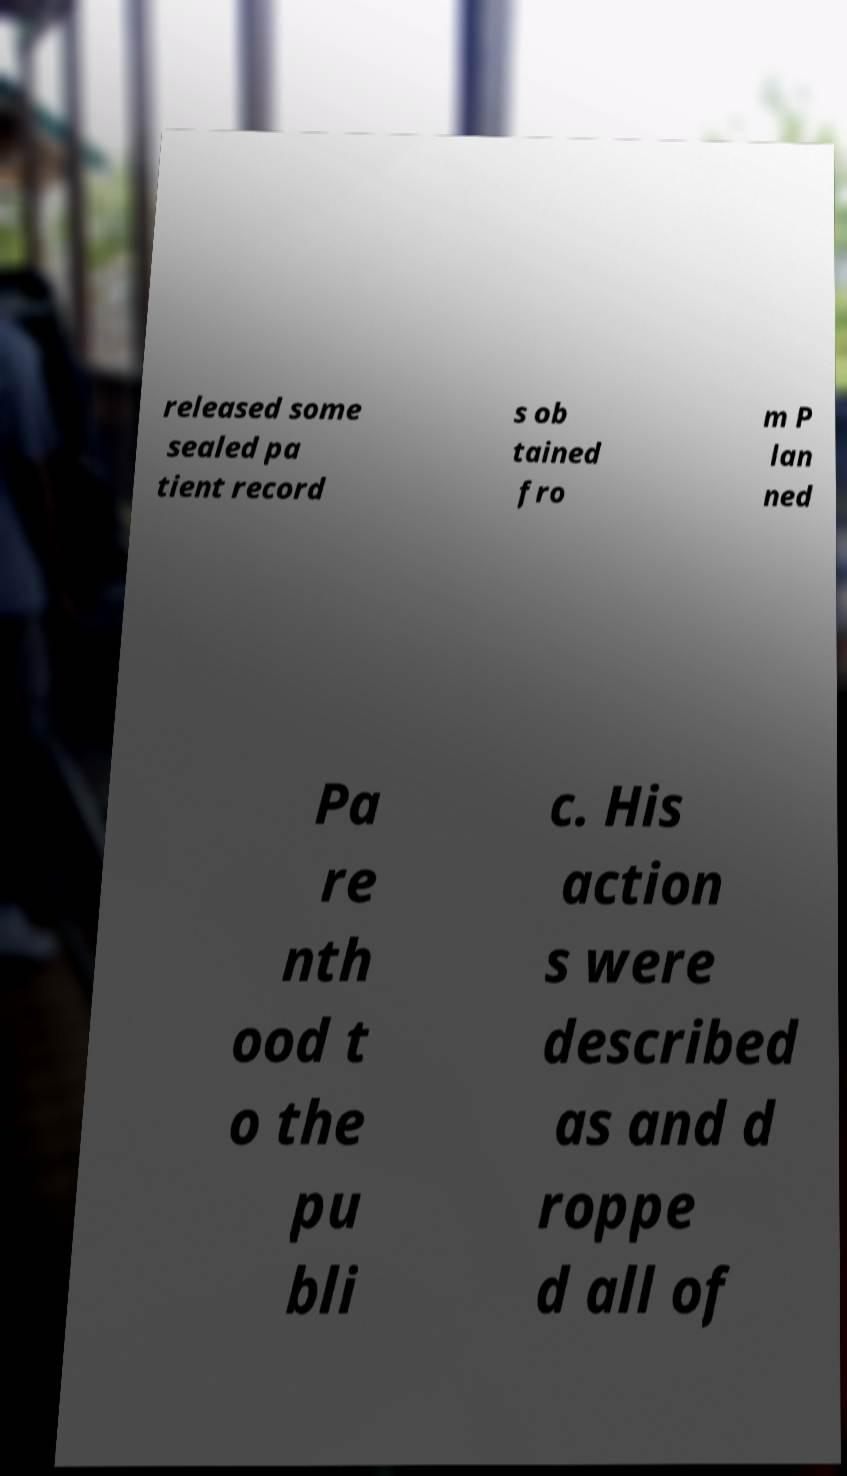I need the written content from this picture converted into text. Can you do that? released some sealed pa tient record s ob tained fro m P lan ned Pa re nth ood t o the pu bli c. His action s were described as and d roppe d all of 